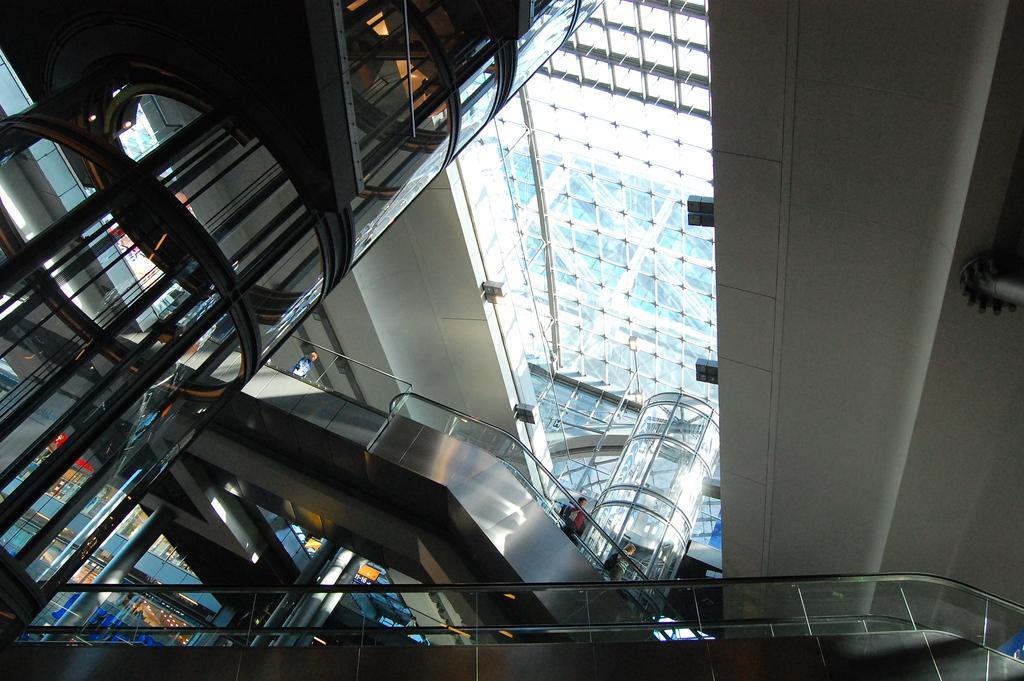In one or two sentences, can you explain what this image depicts? At the top we can see the glass ceiling. This is an inside view picture of a building. In this picture we can see people, escalators and railings. On the left side we can see the glass elevators. 